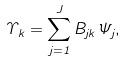Convert formula to latex. <formula><loc_0><loc_0><loc_500><loc_500>\Upsilon _ { k } = \sum _ { j = 1 } ^ { J } B _ { j k } \Psi _ { j } ,</formula> 